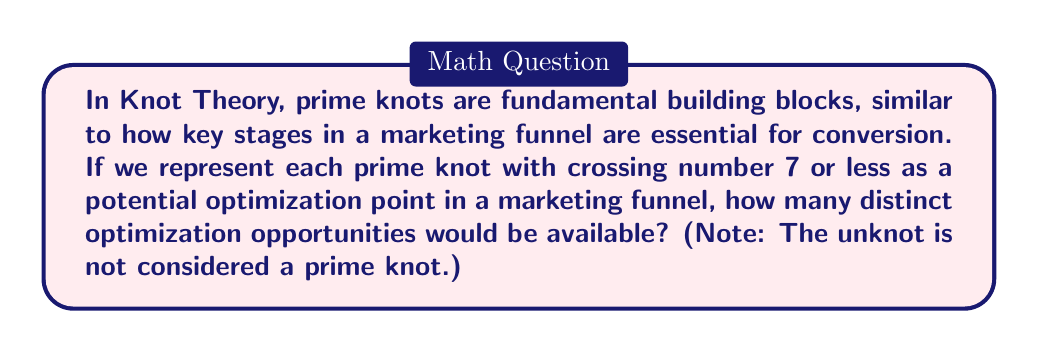Teach me how to tackle this problem. To solve this problem, we need to identify all prime knots with crossing number 7 or less. Let's break it down by crossing number:

1. Crossing number 3:
   - The trefoil knot (3₁)

2. Crossing number 4:
   - The figure-eight knot (4₁)

3. Crossing number 5:
   - The cinquefoil knot (5₁)
   - The three-twist knot (5₂)

4. Crossing number 6:
   - No prime knots with 6 crossings exist

5. Crossing number 7:
   - 7₁ knot
   - 7₂ knot
   - 7₃ knot
   - 7₄ knot
   - 7₅ knot
   - 7₆ knot
   - 7₇ knot

To calculate the total number of prime knots, we sum up the counts for each crossing number:

$$1 + 1 + 2 + 0 + 7 = 11$$

Therefore, there are 11 distinct prime knots with crossing number 7 or less, representing 11 potential optimization points in a marketing funnel.
Answer: 11 